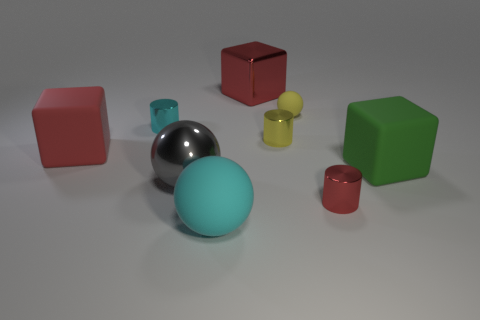What number of balls are green things or large red metal objects?
Keep it short and to the point. 0. There is a ball that is behind the cube that is in front of the large rubber block that is behind the green block; what size is it?
Make the answer very short. Small. There is a cyan matte object that is the same shape as the gray object; what is its size?
Your response must be concise. Large. There is a small cyan object; what number of large red things are behind it?
Offer a terse response. 1. Does the large object to the right of the yellow matte sphere have the same color as the metallic block?
Your answer should be very brief. No. How many cyan things are either matte spheres or large things?
Make the answer very short. 1. The tiny object behind the tiny metal object that is on the left side of the red metal block is what color?
Your response must be concise. Yellow. What material is the thing that is the same color as the tiny ball?
Make the answer very short. Metal. What color is the matte sphere that is on the right side of the big red metallic thing?
Your response must be concise. Yellow. There is a rubber block that is to the left of the red cylinder; is its size the same as the red cylinder?
Offer a very short reply. No. 